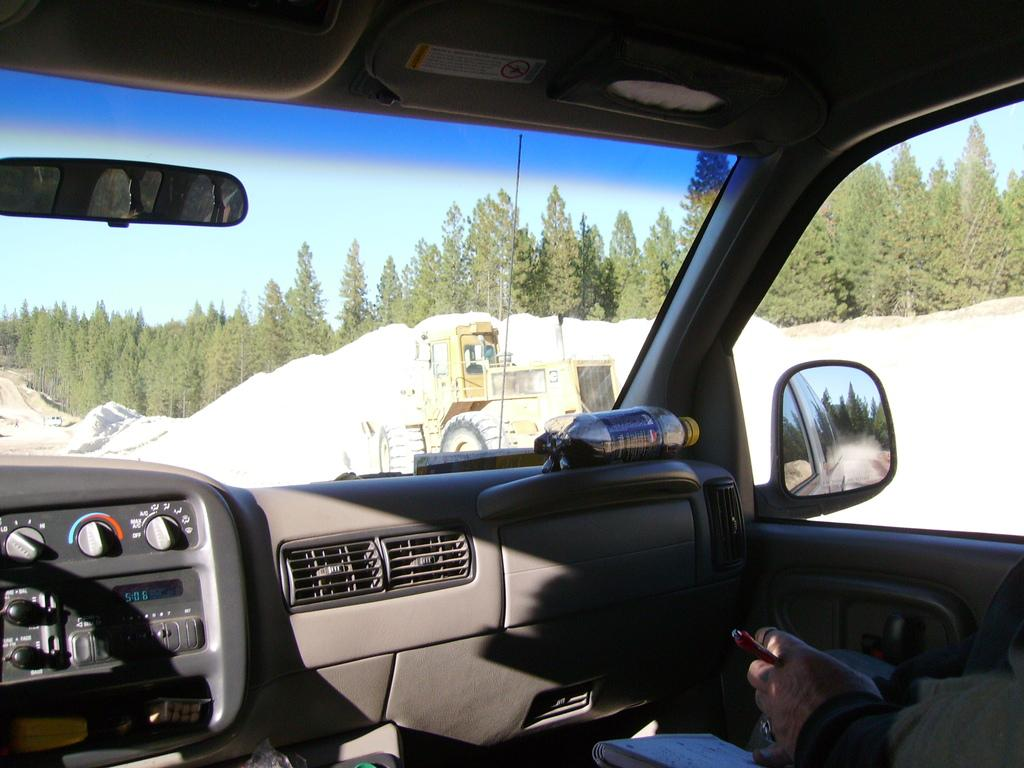What type of location is depicted in the image? The image is an inside view of a car. Can you describe the person in the car? There is a person in the car, but their appearance or actions are not specified in the facts. What items can be seen in the car? There is a book and a bottle in the car. What features are present in the car? There are mirrors and glasses in the car. What can be seen outside the car through the glass? There is a vehicle, land, trees, and the sky visible behind the glass. What type of dinner is being prepared in the image? There is no mention of dinner or any food preparation in the image. Can you see any cobwebs in the car? The facts provided do not mention any cobwebs in the car. 